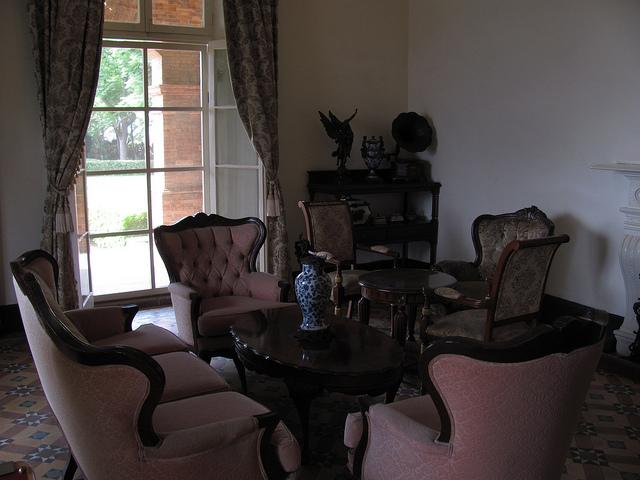Is it daytime or nighttime?
Answer briefly. Daytime. Are the curtains open?
Concise answer only. Yes. Is there sunlight coming in the window?
Be succinct. Yes. 